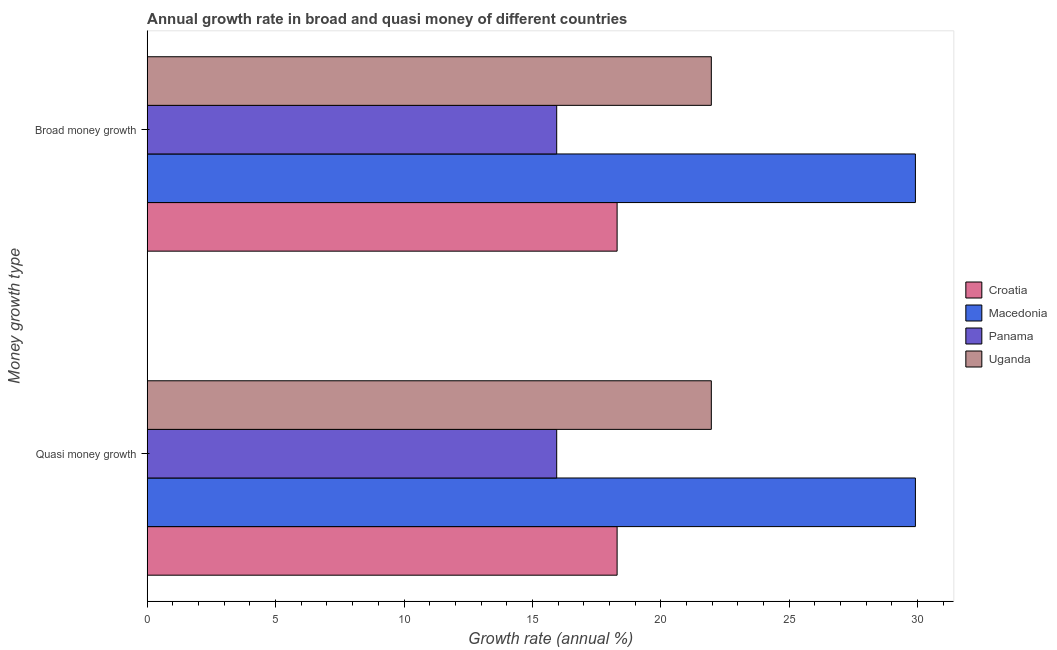How many different coloured bars are there?
Keep it short and to the point. 4. Are the number of bars on each tick of the Y-axis equal?
Your response must be concise. Yes. How many bars are there on the 2nd tick from the bottom?
Keep it short and to the point. 4. What is the label of the 1st group of bars from the top?
Make the answer very short. Broad money growth. What is the annual growth rate in quasi money in Macedonia?
Offer a terse response. 29.91. Across all countries, what is the maximum annual growth rate in broad money?
Keep it short and to the point. 29.91. Across all countries, what is the minimum annual growth rate in broad money?
Your answer should be compact. 15.95. In which country was the annual growth rate in quasi money maximum?
Make the answer very short. Macedonia. In which country was the annual growth rate in broad money minimum?
Offer a terse response. Panama. What is the total annual growth rate in quasi money in the graph?
Make the answer very short. 86.12. What is the difference between the annual growth rate in quasi money in Panama and that in Croatia?
Offer a terse response. -2.35. What is the difference between the annual growth rate in quasi money in Croatia and the annual growth rate in broad money in Panama?
Offer a terse response. 2.35. What is the average annual growth rate in broad money per country?
Keep it short and to the point. 21.53. In how many countries, is the annual growth rate in broad money greater than 30 %?
Ensure brevity in your answer.  0. What is the ratio of the annual growth rate in broad money in Panama to that in Uganda?
Keep it short and to the point. 0.73. In how many countries, is the annual growth rate in quasi money greater than the average annual growth rate in quasi money taken over all countries?
Your response must be concise. 2. What does the 3rd bar from the top in Broad money growth represents?
Provide a short and direct response. Macedonia. What does the 1st bar from the bottom in Quasi money growth represents?
Your response must be concise. Croatia. Are all the bars in the graph horizontal?
Provide a short and direct response. Yes. Does the graph contain any zero values?
Offer a very short reply. No. Does the graph contain grids?
Provide a short and direct response. No. Where does the legend appear in the graph?
Provide a short and direct response. Center right. How many legend labels are there?
Provide a short and direct response. 4. How are the legend labels stacked?
Ensure brevity in your answer.  Vertical. What is the title of the graph?
Keep it short and to the point. Annual growth rate in broad and quasi money of different countries. What is the label or title of the X-axis?
Offer a terse response. Growth rate (annual %). What is the label or title of the Y-axis?
Ensure brevity in your answer.  Money growth type. What is the Growth rate (annual %) in Croatia in Quasi money growth?
Your answer should be very brief. 18.3. What is the Growth rate (annual %) of Macedonia in Quasi money growth?
Your response must be concise. 29.91. What is the Growth rate (annual %) in Panama in Quasi money growth?
Provide a succinct answer. 15.95. What is the Growth rate (annual %) in Uganda in Quasi money growth?
Give a very brief answer. 21.97. What is the Growth rate (annual %) of Croatia in Broad money growth?
Your response must be concise. 18.3. What is the Growth rate (annual %) of Macedonia in Broad money growth?
Make the answer very short. 29.91. What is the Growth rate (annual %) in Panama in Broad money growth?
Your answer should be compact. 15.95. What is the Growth rate (annual %) of Uganda in Broad money growth?
Your response must be concise. 21.97. Across all Money growth type, what is the maximum Growth rate (annual %) in Croatia?
Provide a succinct answer. 18.3. Across all Money growth type, what is the maximum Growth rate (annual %) of Macedonia?
Ensure brevity in your answer.  29.91. Across all Money growth type, what is the maximum Growth rate (annual %) in Panama?
Give a very brief answer. 15.95. Across all Money growth type, what is the maximum Growth rate (annual %) in Uganda?
Give a very brief answer. 21.97. Across all Money growth type, what is the minimum Growth rate (annual %) in Croatia?
Make the answer very short. 18.3. Across all Money growth type, what is the minimum Growth rate (annual %) of Macedonia?
Your response must be concise. 29.91. Across all Money growth type, what is the minimum Growth rate (annual %) in Panama?
Give a very brief answer. 15.95. Across all Money growth type, what is the minimum Growth rate (annual %) in Uganda?
Provide a short and direct response. 21.97. What is the total Growth rate (annual %) of Croatia in the graph?
Offer a terse response. 36.59. What is the total Growth rate (annual %) in Macedonia in the graph?
Provide a succinct answer. 59.82. What is the total Growth rate (annual %) of Panama in the graph?
Provide a succinct answer. 31.89. What is the total Growth rate (annual %) of Uganda in the graph?
Your answer should be very brief. 43.93. What is the difference between the Growth rate (annual %) in Croatia in Quasi money growth and that in Broad money growth?
Your response must be concise. 0. What is the difference between the Growth rate (annual %) of Macedonia in Quasi money growth and that in Broad money growth?
Your answer should be compact. 0. What is the difference between the Growth rate (annual %) in Panama in Quasi money growth and that in Broad money growth?
Your response must be concise. 0. What is the difference between the Growth rate (annual %) of Uganda in Quasi money growth and that in Broad money growth?
Keep it short and to the point. 0. What is the difference between the Growth rate (annual %) in Croatia in Quasi money growth and the Growth rate (annual %) in Macedonia in Broad money growth?
Offer a terse response. -11.61. What is the difference between the Growth rate (annual %) of Croatia in Quasi money growth and the Growth rate (annual %) of Panama in Broad money growth?
Give a very brief answer. 2.35. What is the difference between the Growth rate (annual %) of Croatia in Quasi money growth and the Growth rate (annual %) of Uganda in Broad money growth?
Ensure brevity in your answer.  -3.67. What is the difference between the Growth rate (annual %) of Macedonia in Quasi money growth and the Growth rate (annual %) of Panama in Broad money growth?
Offer a terse response. 13.97. What is the difference between the Growth rate (annual %) in Macedonia in Quasi money growth and the Growth rate (annual %) in Uganda in Broad money growth?
Ensure brevity in your answer.  7.95. What is the difference between the Growth rate (annual %) of Panama in Quasi money growth and the Growth rate (annual %) of Uganda in Broad money growth?
Ensure brevity in your answer.  -6.02. What is the average Growth rate (annual %) of Croatia per Money growth type?
Offer a terse response. 18.3. What is the average Growth rate (annual %) of Macedonia per Money growth type?
Your response must be concise. 29.91. What is the average Growth rate (annual %) in Panama per Money growth type?
Make the answer very short. 15.95. What is the average Growth rate (annual %) of Uganda per Money growth type?
Ensure brevity in your answer.  21.97. What is the difference between the Growth rate (annual %) in Croatia and Growth rate (annual %) in Macedonia in Quasi money growth?
Your answer should be compact. -11.61. What is the difference between the Growth rate (annual %) in Croatia and Growth rate (annual %) in Panama in Quasi money growth?
Offer a terse response. 2.35. What is the difference between the Growth rate (annual %) of Croatia and Growth rate (annual %) of Uganda in Quasi money growth?
Ensure brevity in your answer.  -3.67. What is the difference between the Growth rate (annual %) in Macedonia and Growth rate (annual %) in Panama in Quasi money growth?
Provide a succinct answer. 13.97. What is the difference between the Growth rate (annual %) of Macedonia and Growth rate (annual %) of Uganda in Quasi money growth?
Keep it short and to the point. 7.95. What is the difference between the Growth rate (annual %) of Panama and Growth rate (annual %) of Uganda in Quasi money growth?
Ensure brevity in your answer.  -6.02. What is the difference between the Growth rate (annual %) in Croatia and Growth rate (annual %) in Macedonia in Broad money growth?
Your answer should be very brief. -11.61. What is the difference between the Growth rate (annual %) in Croatia and Growth rate (annual %) in Panama in Broad money growth?
Your response must be concise. 2.35. What is the difference between the Growth rate (annual %) of Croatia and Growth rate (annual %) of Uganda in Broad money growth?
Your response must be concise. -3.67. What is the difference between the Growth rate (annual %) of Macedonia and Growth rate (annual %) of Panama in Broad money growth?
Provide a succinct answer. 13.97. What is the difference between the Growth rate (annual %) of Macedonia and Growth rate (annual %) of Uganda in Broad money growth?
Keep it short and to the point. 7.95. What is the difference between the Growth rate (annual %) in Panama and Growth rate (annual %) in Uganda in Broad money growth?
Keep it short and to the point. -6.02. What is the ratio of the Growth rate (annual %) of Panama in Quasi money growth to that in Broad money growth?
Give a very brief answer. 1. What is the ratio of the Growth rate (annual %) in Uganda in Quasi money growth to that in Broad money growth?
Make the answer very short. 1. What is the difference between the highest and the second highest Growth rate (annual %) of Croatia?
Your answer should be very brief. 0. What is the difference between the highest and the second highest Growth rate (annual %) in Macedonia?
Offer a very short reply. 0. What is the difference between the highest and the lowest Growth rate (annual %) in Panama?
Provide a succinct answer. 0. What is the difference between the highest and the lowest Growth rate (annual %) of Uganda?
Offer a very short reply. 0. 